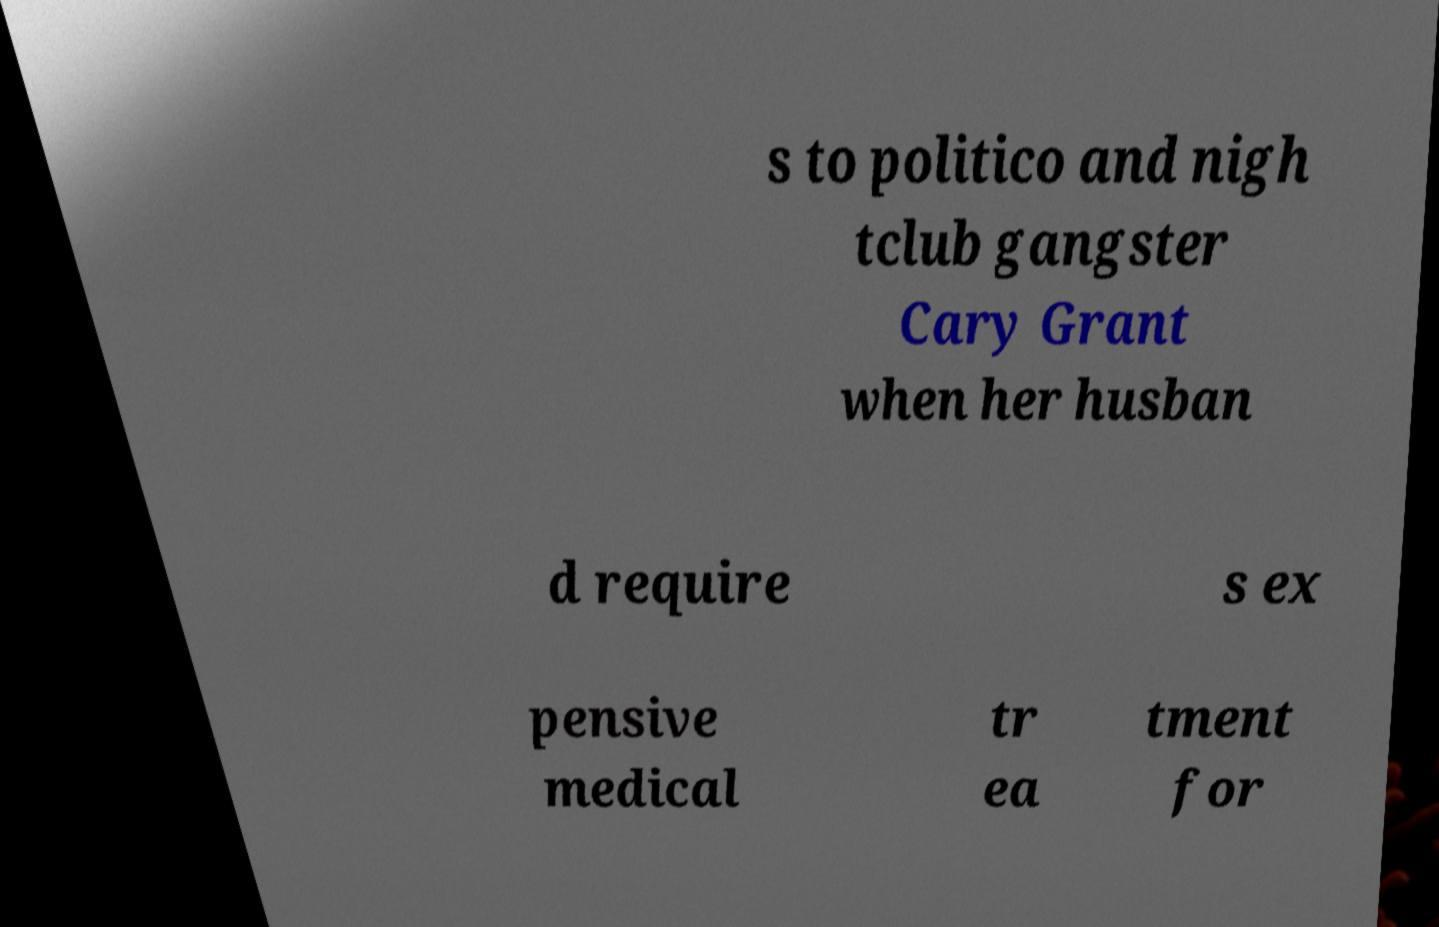Please identify and transcribe the text found in this image. s to politico and nigh tclub gangster Cary Grant when her husban d require s ex pensive medical tr ea tment for 